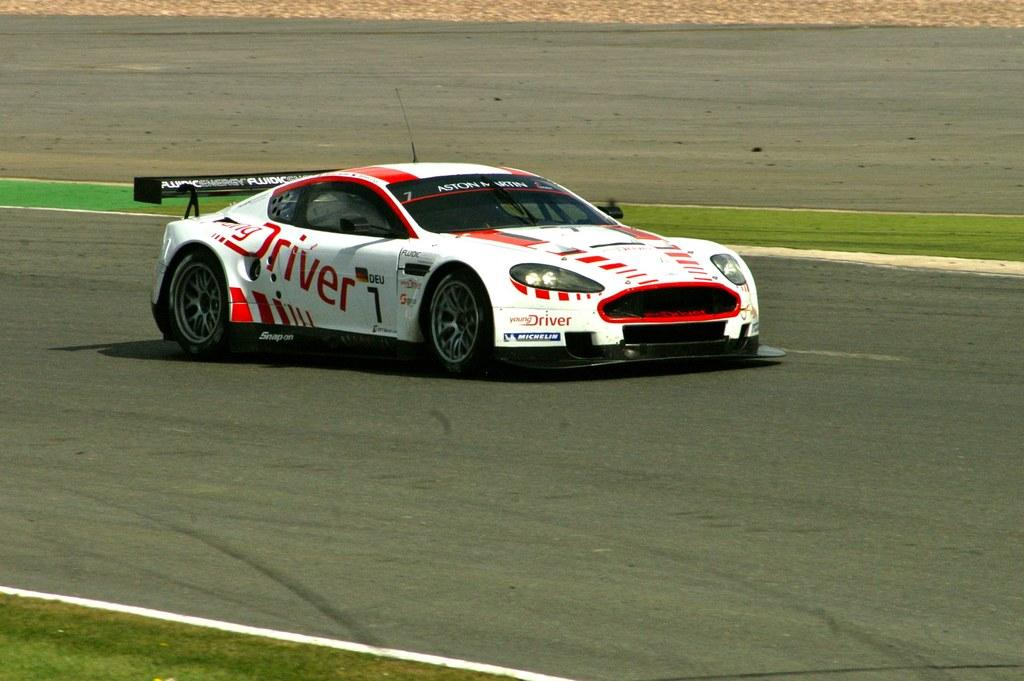What is the main subject of the image? There is a vehicle on the road in the image. Can you describe any specific features of the vehicle? The vehicle has text on it. What type of natural environment can be seen in the image? There is grass visible in the image. What type of dirt can be seen on the surface of the moon in the image? There is no moon or dirt present in the image; it features a vehicle on the road with grass in the background. 